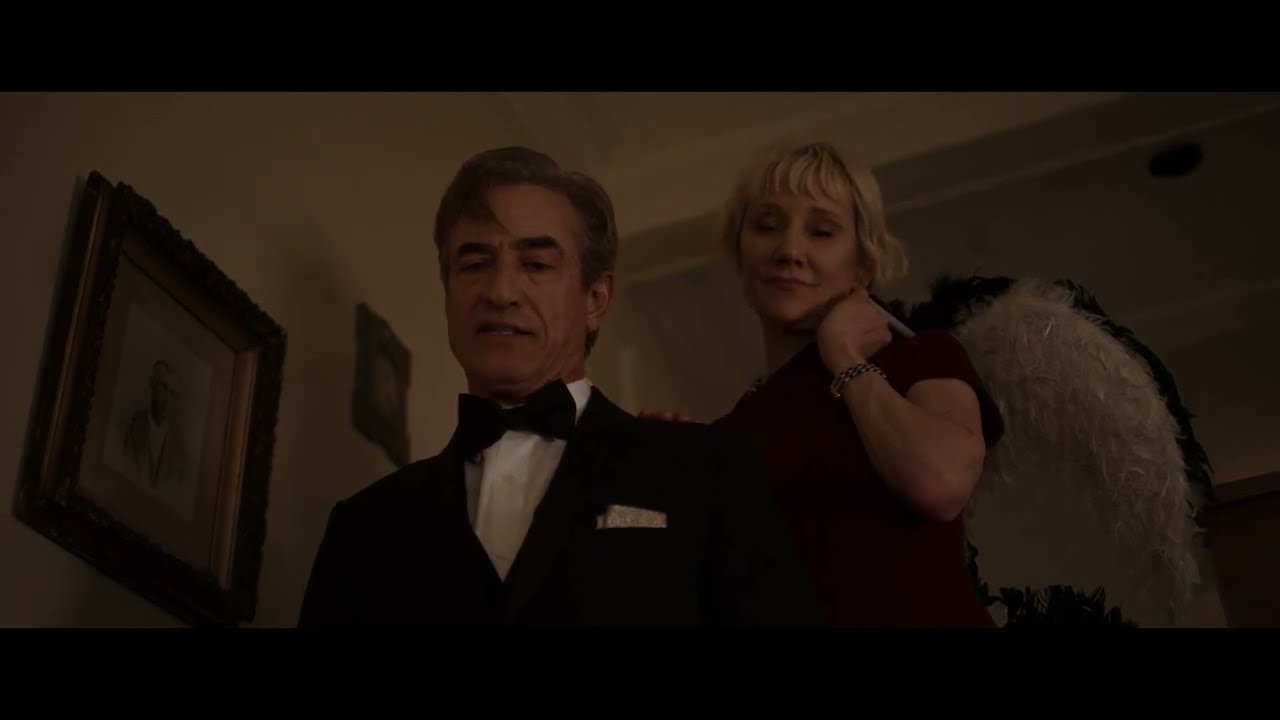Can you imagine a whimsical fantasy storyline based on this image? In a magical realm where art comes to life, the man in the tuxedo is a noble guardian who protects enchanted paintings. The woman, a mystical enchantress, wields the power of the feathered boa to bring fantastical elements into reality. The painting behind them is no ordinary artwork but a portal to a hidden world. As they stand together, the enchantress senses a disturbance in the enchanted realm and prepares to step through the portal, leading the guardian into a whimsical adventure to restore balance and harmony. Describe the enchanted realm they are about to enter. The enchanted realm they are about to enter is a breathtaking wonderland, where vibrant colors and surreal landscapes stretch as far as the eye can see. Giant, luminescent flowers bloom under a sky painted with swirling galaxies, and rivers of liquid light weave through the lush terrain. Magical creatures, from ethereal butterflies to majestic winged lions, inhabit this world, their presence adding to the dreamlike atmosphere. The air is filled with a harmonious melody, the very essence of magic resonating through every leaf and stone. This realm is a sanctuary of forgotten dreams and untold stories, waiting to be discovered by those who dare to step through the portal. 